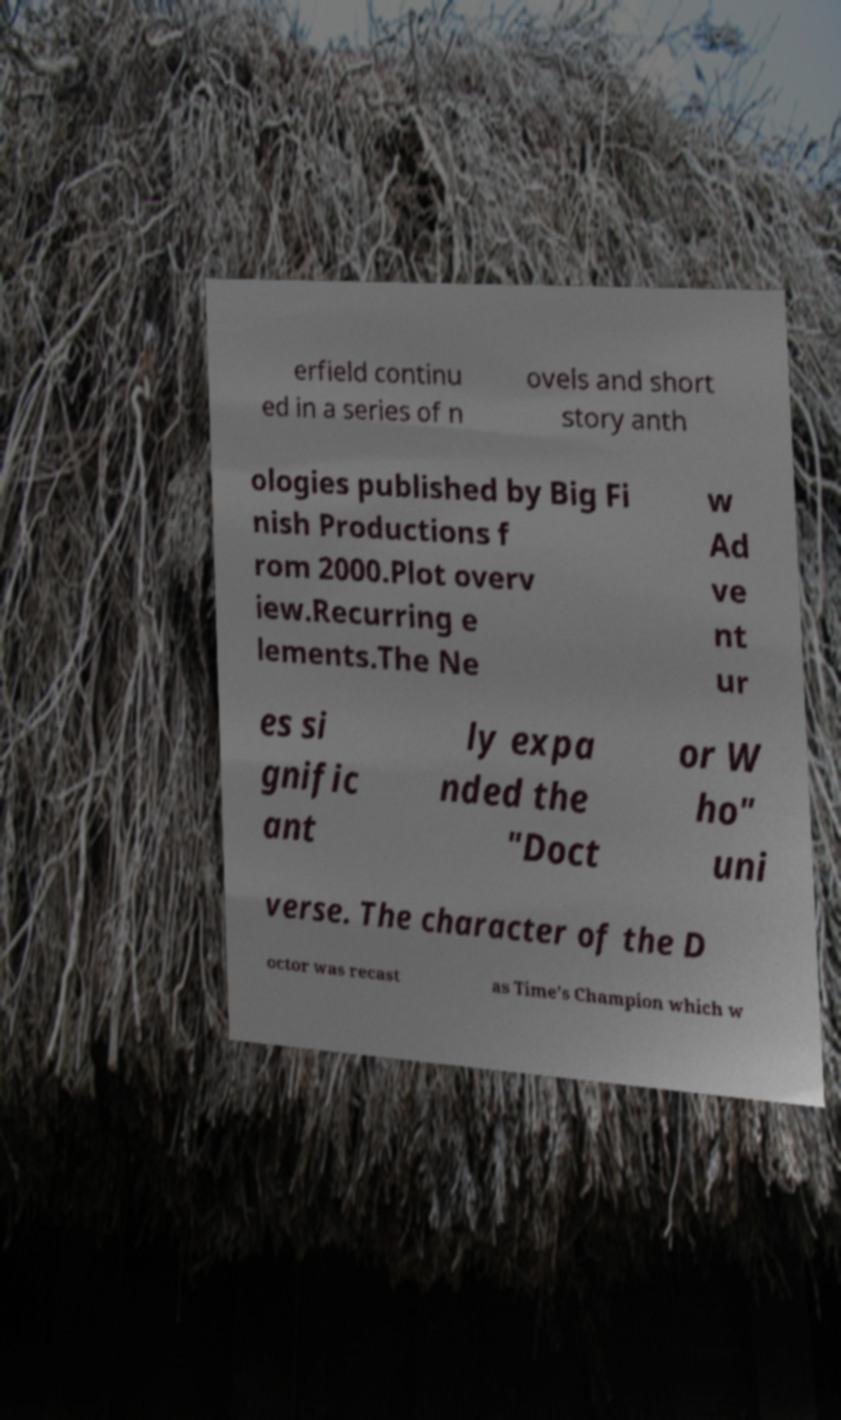What messages or text are displayed in this image? I need them in a readable, typed format. erfield continu ed in a series of n ovels and short story anth ologies published by Big Fi nish Productions f rom 2000.Plot overv iew.Recurring e lements.The Ne w Ad ve nt ur es si gnific ant ly expa nded the "Doct or W ho" uni verse. The character of the D octor was recast as Time's Champion which w 